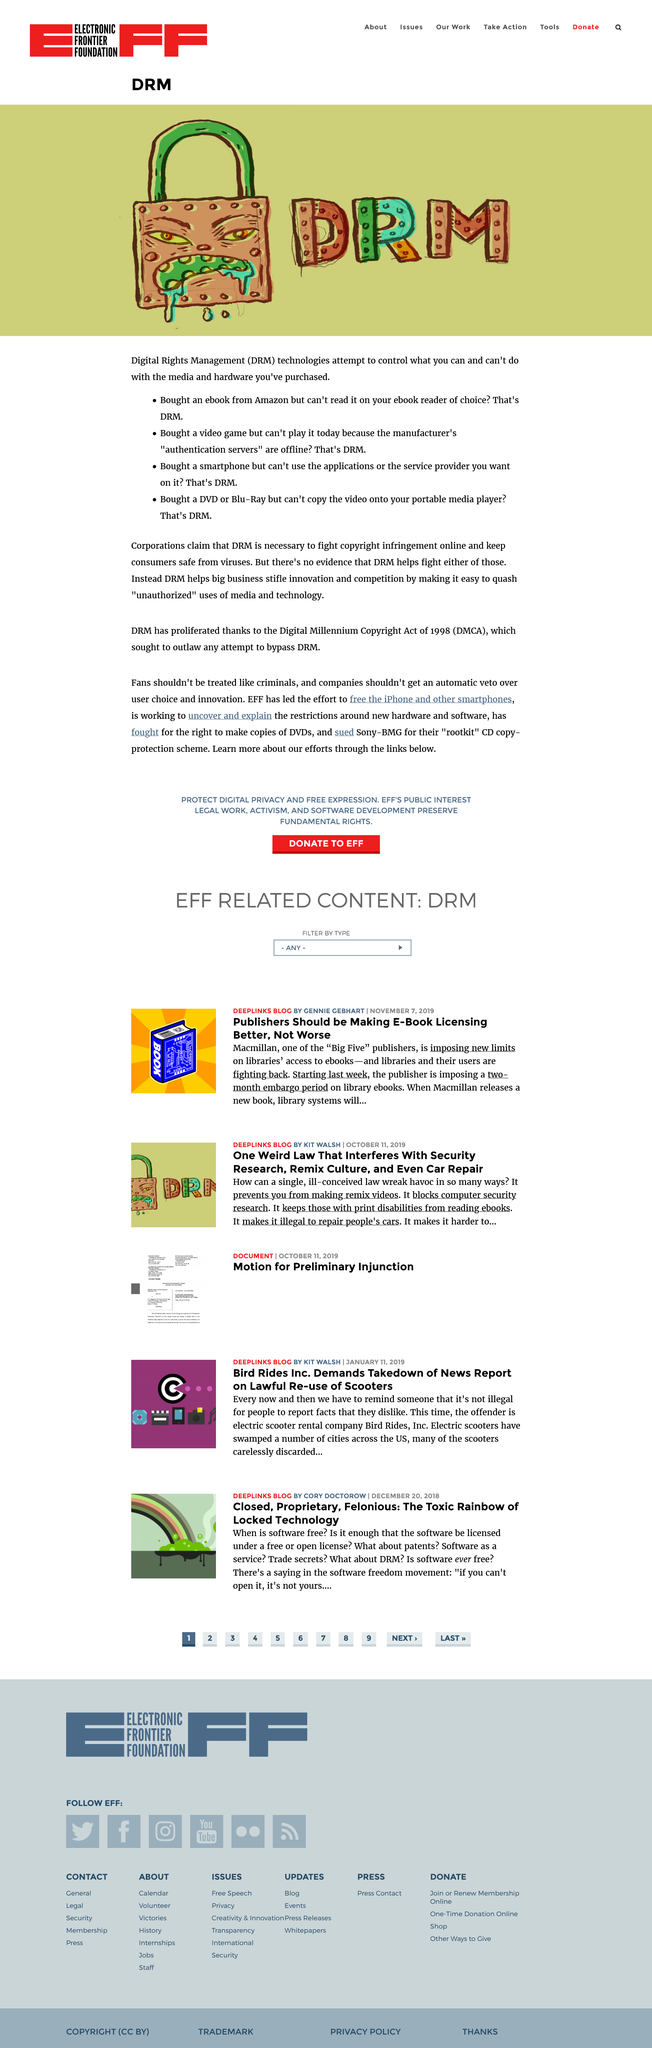Give some essential details in this illustration. DRM technologies seek to restrict the usage rights of media and hardware that consumers have lawfully purchased, in an effort to control what they can and cannot do with their own property. The initials shown in the image represent "DRM," which stands for "Digital Rights Management. Corporations claim that DRM is necessary to combat online copyright infringement and protect consumers from viruses. 